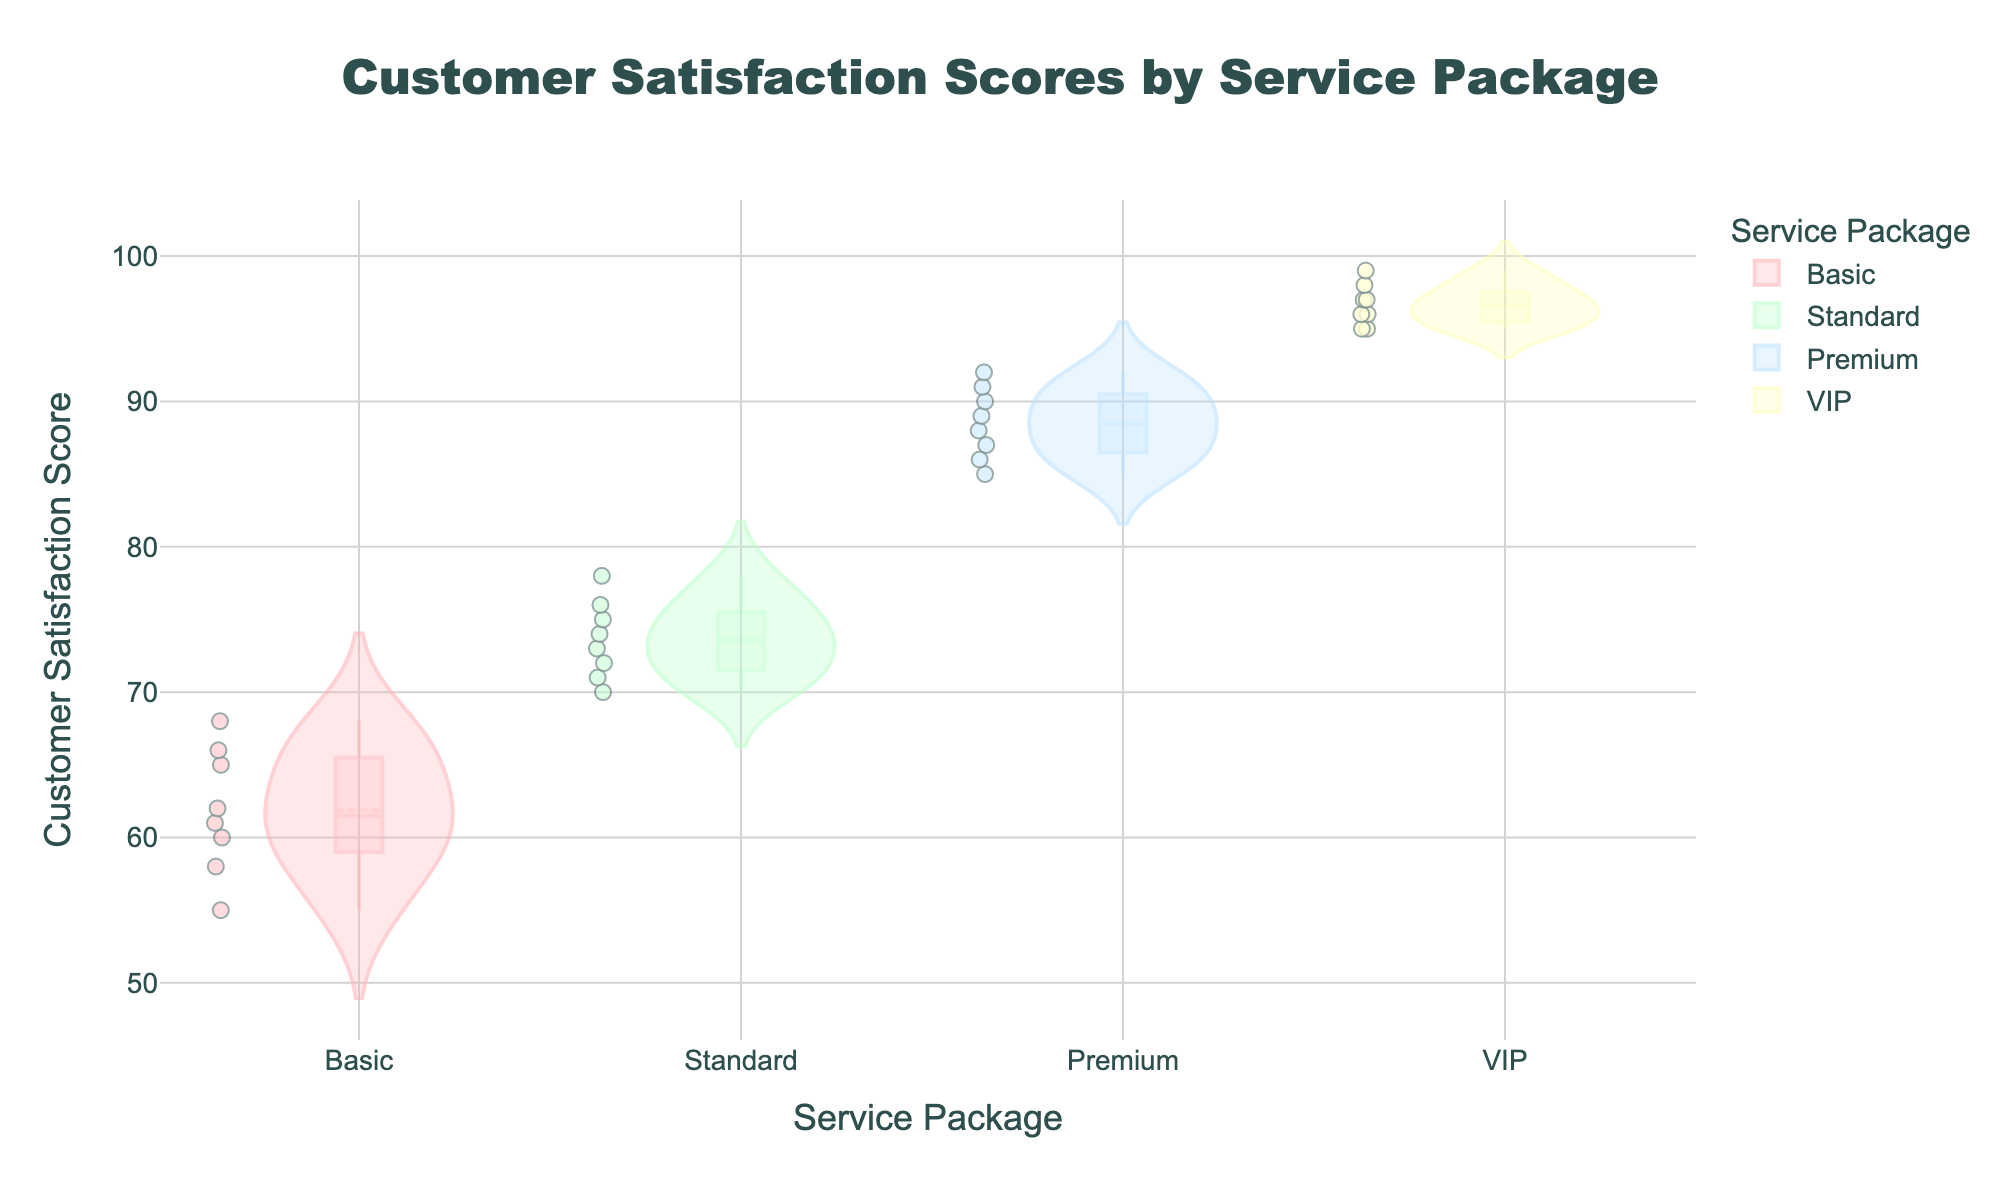What's the title of the figure? The title is usually displayed at the top of the figure. In this figure, the title text is "Customer Satisfaction Scores by Service Package".
Answer: Customer Satisfaction Scores by Service Package What are the service packages available in the data? The names of the service packages can be seen along the x-axis. The service packages are "Basic", "Standard", "Premium", and "VIP".
Answer: Basic, Standard, Premium, VIP Which service package has the highest median customer satisfaction score? The box plot's median line is visible within the violins. The median lines for the "VIP" package are at higher satisfaction levels compared to the other packages.
Answer: VIP Which service package has the widest range of customer satisfaction scores? The range is the distance between the minimum and maximum points in the violin plot. The "Basic" package has the widest violin and box plot spread, indicating the widest range of scores.
Answer: Basic How does the interquartile range (IQR) of the "Standard" package compare to the "Premium" package? The IQR is the box portion of the box plot. The "Standard" package has a smaller box compared to the "Premium", indicating a narrower IQR.
Answer: The "Standard" package has a smaller IQR than the "Premium" package Which service package shows the most clustered customer satisfaction scores? Clustered points are indicated by less spread in the violin plot. The "VIP" package shows a very narrow and tight distribution of scores.
Answer: VIP Are there any outliers in the data, and if so, for which service package? Outliers would be individual points outside the main body of the violin and box plot. There are no outliers represented in any of the service packages based on the provided scores.
Answer: No outliers What is the general trend in customer satisfaction scores across the service packages? The trend can be observed through the median lines and overall distribution in the violin plots. The scores increase from "Basic" to "VIP".
Answer: Increasing trend from Basic to VIP Comparing "Basic" and "Standard" packages, which has a higher minimum satisfaction score? The minimum score is the lowest point in the violin plot. The "Standard" package has a higher bottom end compared to the "Basic" package.
Answer: Standard 